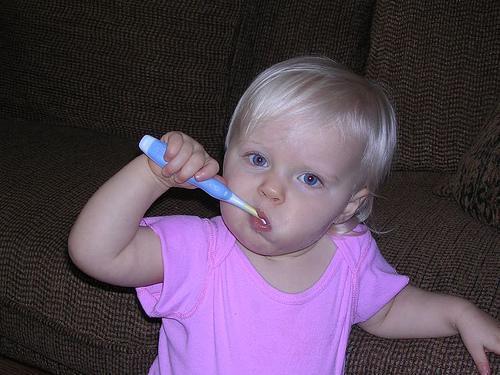How many sinks are on the counter?
Give a very brief answer. 0. 